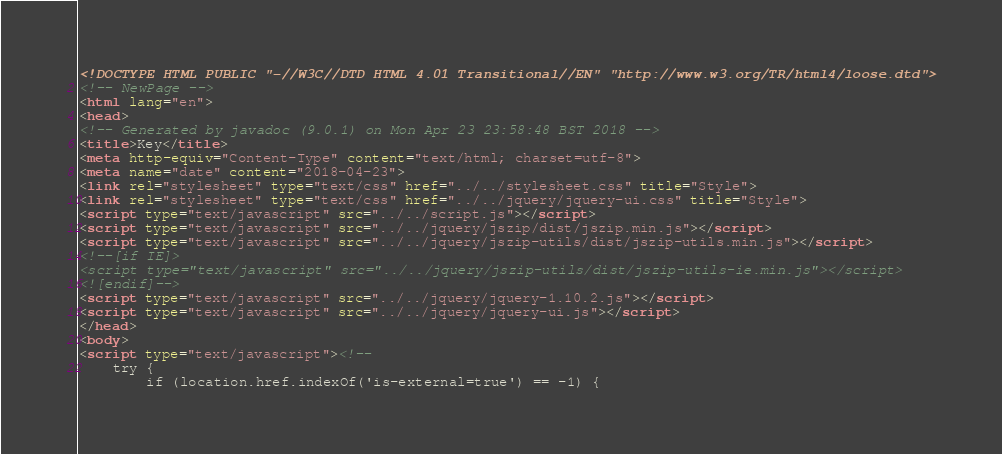Convert code to text. <code><loc_0><loc_0><loc_500><loc_500><_HTML_><!DOCTYPE HTML PUBLIC "-//W3C//DTD HTML 4.01 Transitional//EN" "http://www.w3.org/TR/html4/loose.dtd">
<!-- NewPage -->
<html lang="en">
<head>
<!-- Generated by javadoc (9.0.1) on Mon Apr 23 23:58:48 BST 2018 -->
<title>Key</title>
<meta http-equiv="Content-Type" content="text/html; charset=utf-8">
<meta name="date" content="2018-04-23">
<link rel="stylesheet" type="text/css" href="../../stylesheet.css" title="Style">
<link rel="stylesheet" type="text/css" href="../../jquery/jquery-ui.css" title="Style">
<script type="text/javascript" src="../../script.js"></script>
<script type="text/javascript" src="../../jquery/jszip/dist/jszip.min.js"></script>
<script type="text/javascript" src="../../jquery/jszip-utils/dist/jszip-utils.min.js"></script>
<!--[if IE]>
<script type="text/javascript" src="../../jquery/jszip-utils/dist/jszip-utils-ie.min.js"></script>
<![endif]-->
<script type="text/javascript" src="../../jquery/jquery-1.10.2.js"></script>
<script type="text/javascript" src="../../jquery/jquery-ui.js"></script>
</head>
<body>
<script type="text/javascript"><!--
    try {
        if (location.href.indexOf('is-external=true') == -1) {</code> 